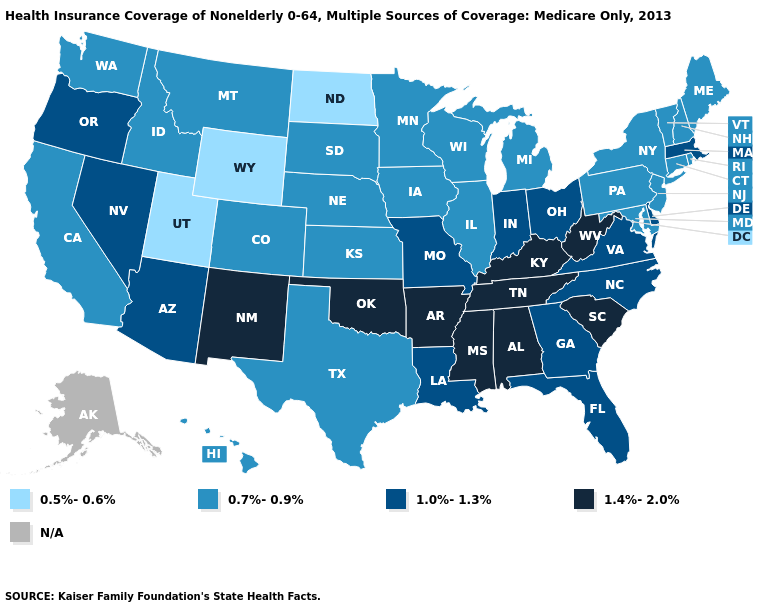What is the lowest value in the USA?
Give a very brief answer. 0.5%-0.6%. Name the states that have a value in the range 0.5%-0.6%?
Quick response, please. North Dakota, Utah, Wyoming. What is the highest value in states that border Kentucky?
Keep it brief. 1.4%-2.0%. Does the map have missing data?
Give a very brief answer. Yes. Name the states that have a value in the range N/A?
Answer briefly. Alaska. Name the states that have a value in the range 0.5%-0.6%?
Write a very short answer. North Dakota, Utah, Wyoming. Which states have the highest value in the USA?
Answer briefly. Alabama, Arkansas, Kentucky, Mississippi, New Mexico, Oklahoma, South Carolina, Tennessee, West Virginia. What is the value of Tennessee?
Quick response, please. 1.4%-2.0%. Which states hav the highest value in the Northeast?
Write a very short answer. Massachusetts. Name the states that have a value in the range N/A?
Keep it brief. Alaska. What is the value of Michigan?
Concise answer only. 0.7%-0.9%. Which states have the lowest value in the USA?
Quick response, please. North Dakota, Utah, Wyoming. Which states have the lowest value in the USA?
Give a very brief answer. North Dakota, Utah, Wyoming. Among the states that border Texas , which have the highest value?
Keep it brief. Arkansas, New Mexico, Oklahoma. 